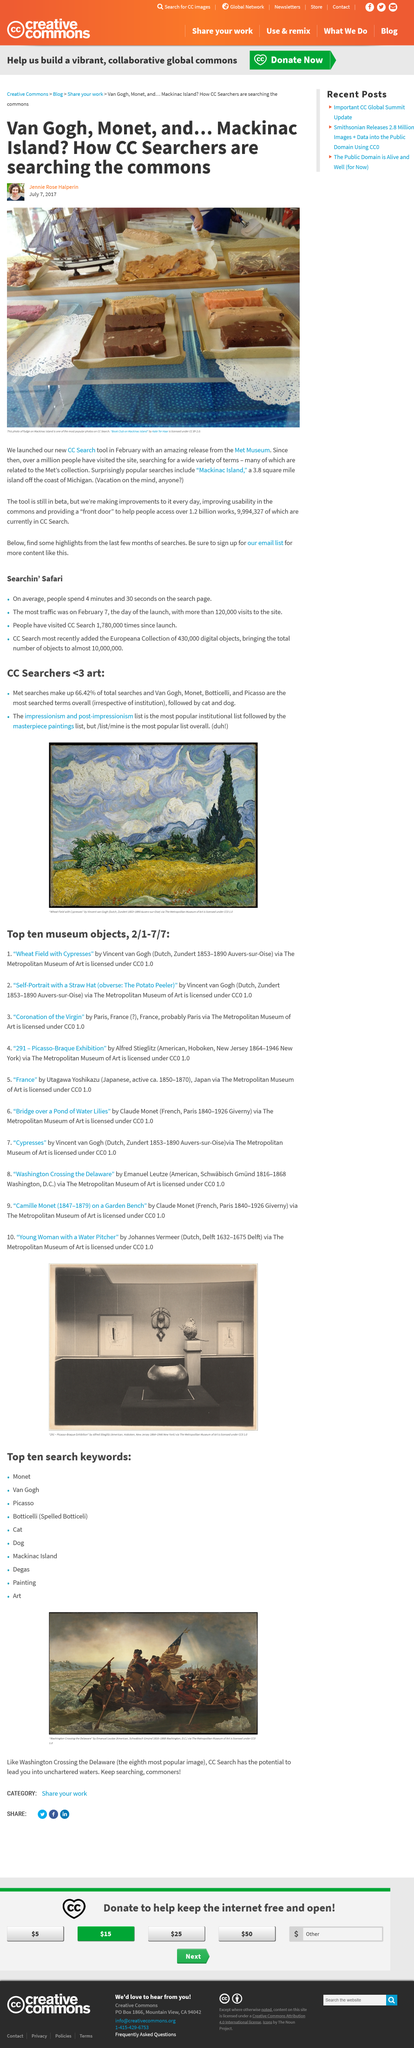Highlight a few significant elements in this photo. Since February, a large number of people have visited the website. The tool is currently in the beta stage of development. Mackinac Island is a 3.8 square mile island located in the Great Lakes region. It is known for its natural beauty, historic sites, and unique culture. 